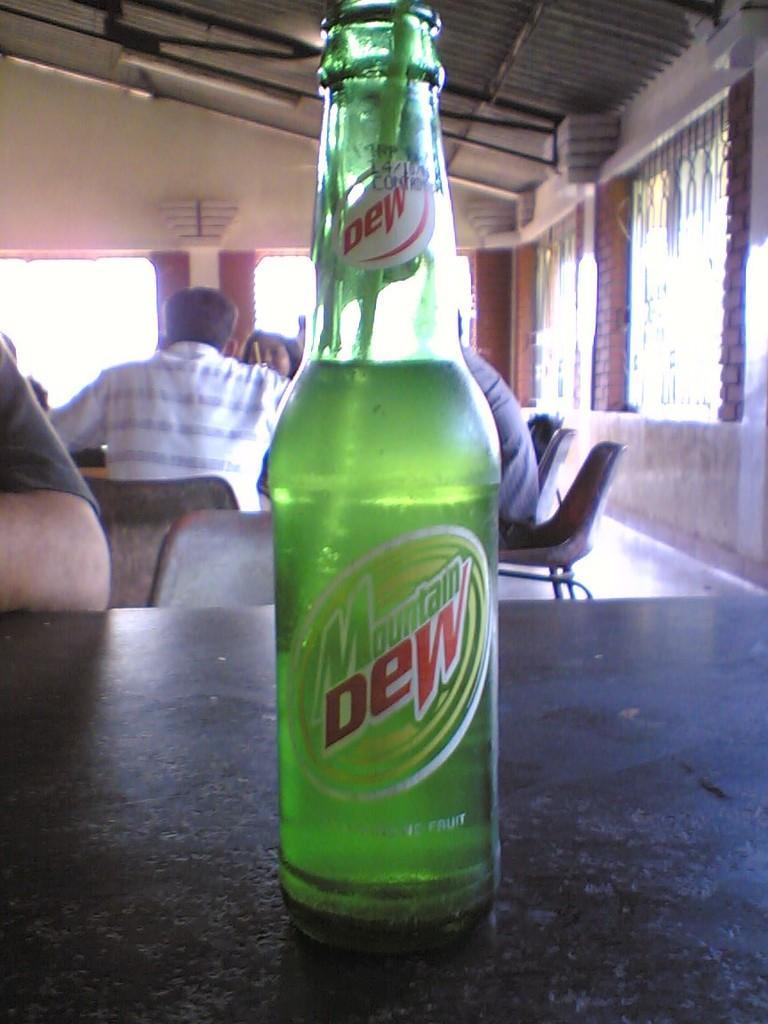Can you describe this image briefly? In this image there is a group of people. There is a bottle on the table, at the top there is a light and at the right there is a window. 